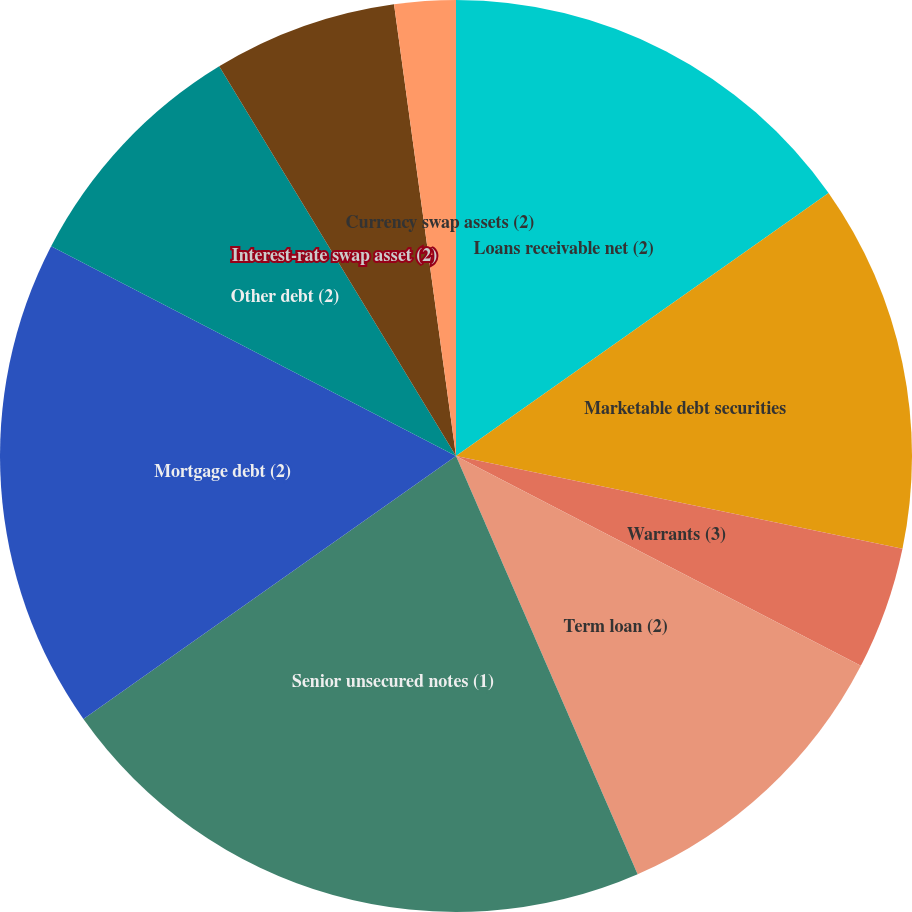Convert chart. <chart><loc_0><loc_0><loc_500><loc_500><pie_chart><fcel>Loans receivable net (2)<fcel>Marketable debt securities<fcel>Warrants (3)<fcel>Term loan (2)<fcel>Senior unsecured notes (1)<fcel>Mortgage debt (2)<fcel>Other debt (2)<fcel>Interest-rate swap asset (2)<fcel>Interest-rate swap liability<fcel>Currency swap assets (2)<nl><fcel>15.22%<fcel>13.04%<fcel>4.35%<fcel>10.87%<fcel>21.74%<fcel>17.39%<fcel>8.7%<fcel>0.0%<fcel>6.52%<fcel>2.17%<nl></chart> 